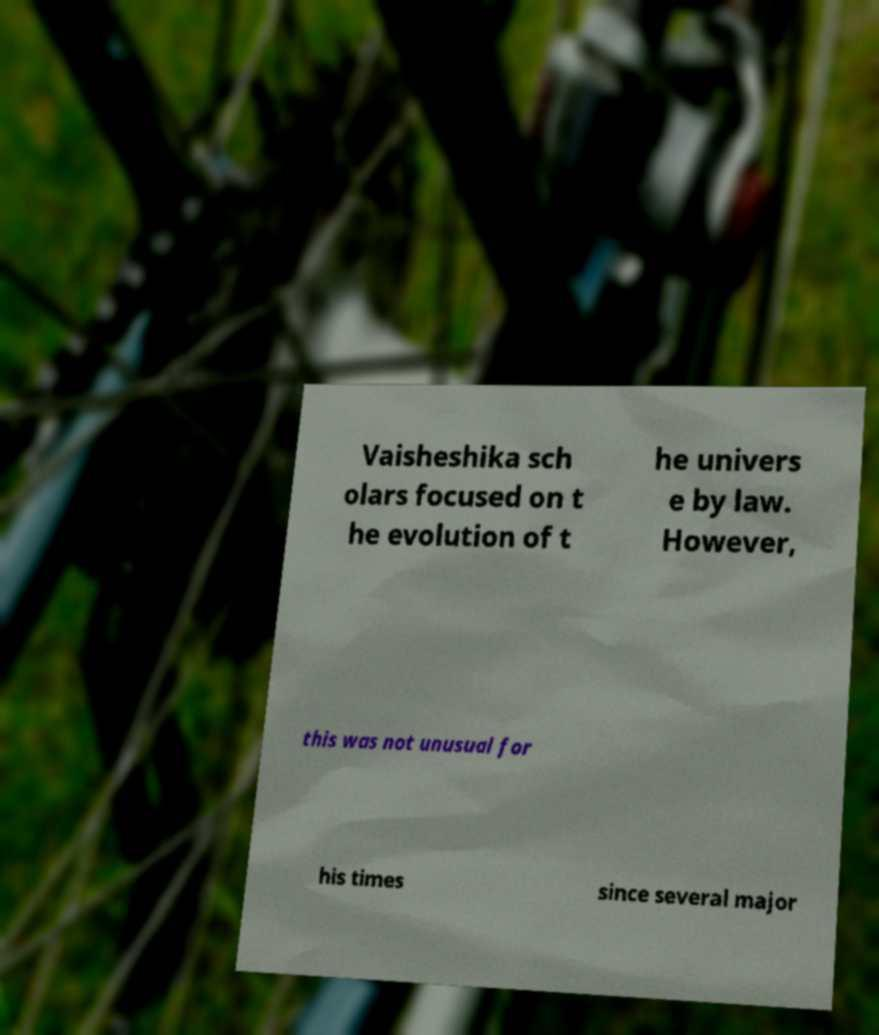There's text embedded in this image that I need extracted. Can you transcribe it verbatim? Vaisheshika sch olars focused on t he evolution of t he univers e by law. However, this was not unusual for his times since several major 